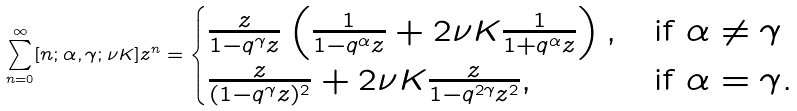Convert formula to latex. <formula><loc_0><loc_0><loc_500><loc_500>\sum _ { n = 0 } ^ { \infty } [ n ; \alpha , \gamma ; \nu K ] z ^ { n } = \begin{cases} \frac { z } { 1 - q ^ { \gamma } z } \left ( \frac { 1 } { 1 - q ^ { \alpha } z } + 2 \nu K \frac { 1 } { 1 + q ^ { \alpha } z } \right ) , & \text {if $\alpha \ne \gamma$} \\ \frac { z } { ( 1 - q ^ { \gamma } z ) ^ { 2 } } + 2 \nu K \frac { z } { 1 - q ^ { 2 \gamma } z ^ { 2 } } , & \text {if $\alpha = \gamma.$} \\ \end{cases}</formula> 